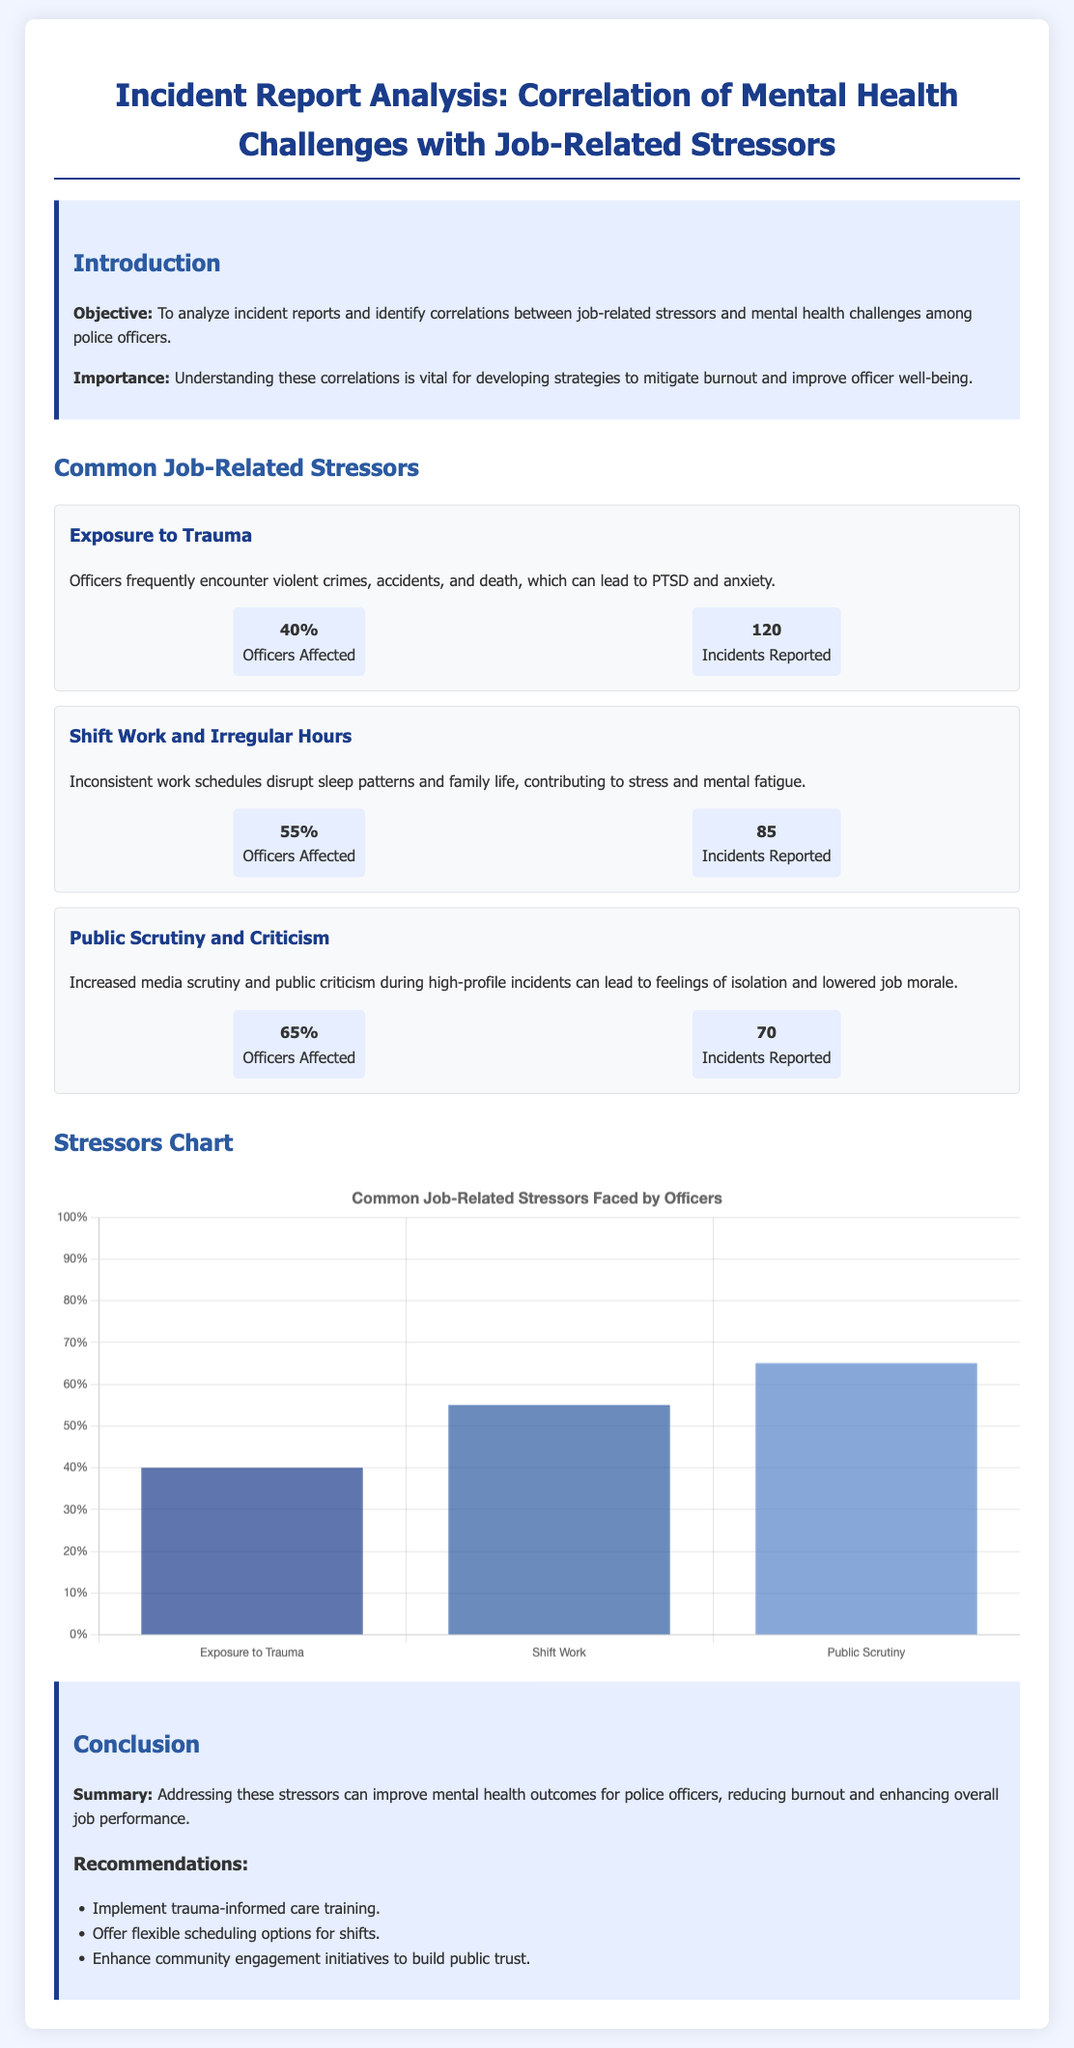what is the objective of the analysis? The objective is to analyze incident reports and identify correlations between job-related stressors and mental health challenges among police officers.
Answer: to analyze incident reports and identify correlations between job-related stressors and mental health challenges among police officers what percentage of officers are affected by public scrutiny? The document states that 65% of officers are affected by public scrutiny and criticism.
Answer: 65% how many incidents of exposure to trauma were reported? The document lists 120 incidents reported regarding exposure to trauma.
Answer: 120 what is one recommendation made in the conclusion? One of the recommendations is to implement trauma-informed care training.
Answer: implement trauma-informed care training which job-related stressor affects the highest percentage of officers? The highest percentage of officers affected is due to public scrutiny and criticism at 65%.
Answer: Public Scrutiny what is the maximum percentage indicated on the y-axis of the stressors chart? The maximum percentage indicated on the y-axis of the stressors chart is 100%.
Answer: 100% how many officers are affected by shift work and irregular hours? The document states that 55% of officers are affected by shift work and irregular hours.
Answer: 55% what is depicted by the stressors chart? The chart depicts the percentage of officers affected by common job-related stressors.
Answer: percentage of officers affected by common job-related stressors 